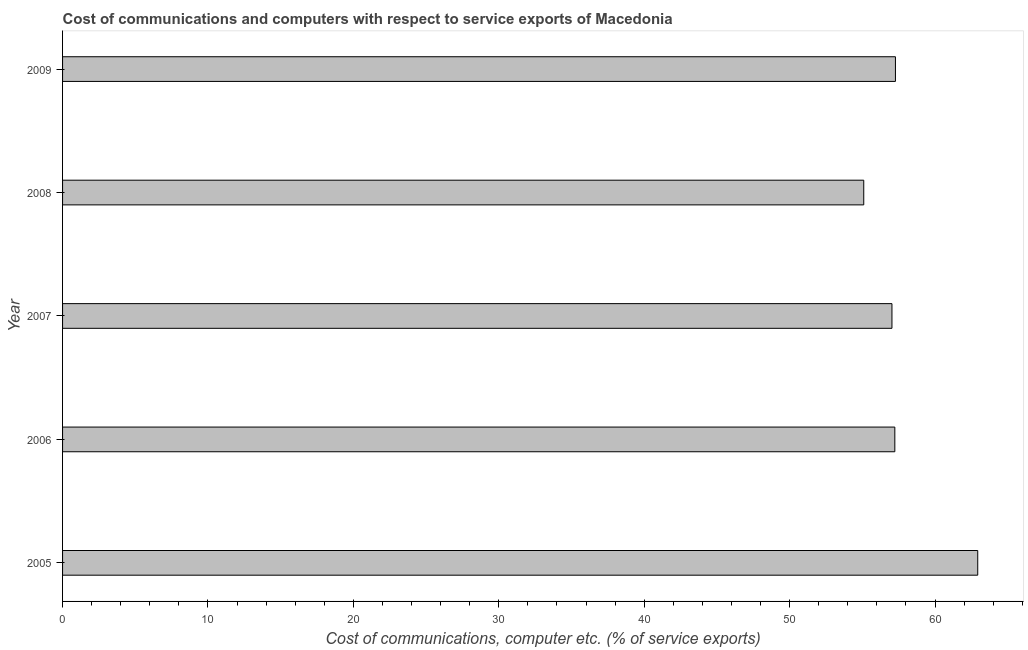Does the graph contain any zero values?
Your answer should be very brief. No. What is the title of the graph?
Provide a succinct answer. Cost of communications and computers with respect to service exports of Macedonia. What is the label or title of the X-axis?
Keep it short and to the point. Cost of communications, computer etc. (% of service exports). What is the cost of communications and computer in 2008?
Offer a terse response. 55.1. Across all years, what is the maximum cost of communications and computer?
Your answer should be compact. 62.94. Across all years, what is the minimum cost of communications and computer?
Your response must be concise. 55.1. In which year was the cost of communications and computer minimum?
Your response must be concise. 2008. What is the sum of the cost of communications and computer?
Offer a very short reply. 289.59. What is the difference between the cost of communications and computer in 2006 and 2009?
Keep it short and to the point. -0.04. What is the average cost of communications and computer per year?
Your response must be concise. 57.92. What is the median cost of communications and computer?
Offer a very short reply. 57.24. In how many years, is the cost of communications and computer greater than 56 %?
Make the answer very short. 4. Do a majority of the years between 2007 and 2005 (inclusive) have cost of communications and computer greater than 60 %?
Offer a terse response. Yes. What is the ratio of the cost of communications and computer in 2005 to that in 2007?
Make the answer very short. 1.1. Is the cost of communications and computer in 2005 less than that in 2008?
Your answer should be very brief. No. Is the difference between the cost of communications and computer in 2007 and 2008 greater than the difference between any two years?
Make the answer very short. No. What is the difference between the highest and the second highest cost of communications and computer?
Provide a short and direct response. 5.66. Is the sum of the cost of communications and computer in 2005 and 2008 greater than the maximum cost of communications and computer across all years?
Offer a terse response. Yes. What is the difference between the highest and the lowest cost of communications and computer?
Your answer should be very brief. 7.84. In how many years, is the cost of communications and computer greater than the average cost of communications and computer taken over all years?
Keep it short and to the point. 1. How many bars are there?
Your response must be concise. 5. Are all the bars in the graph horizontal?
Your answer should be compact. Yes. What is the difference between two consecutive major ticks on the X-axis?
Make the answer very short. 10. Are the values on the major ticks of X-axis written in scientific E-notation?
Make the answer very short. No. What is the Cost of communications, computer etc. (% of service exports) of 2005?
Your response must be concise. 62.94. What is the Cost of communications, computer etc. (% of service exports) in 2006?
Keep it short and to the point. 57.24. What is the Cost of communications, computer etc. (% of service exports) in 2007?
Keep it short and to the point. 57.04. What is the Cost of communications, computer etc. (% of service exports) in 2008?
Keep it short and to the point. 55.1. What is the Cost of communications, computer etc. (% of service exports) in 2009?
Provide a succinct answer. 57.28. What is the difference between the Cost of communications, computer etc. (% of service exports) in 2005 and 2006?
Your answer should be very brief. 5.7. What is the difference between the Cost of communications, computer etc. (% of service exports) in 2005 and 2007?
Keep it short and to the point. 5.9. What is the difference between the Cost of communications, computer etc. (% of service exports) in 2005 and 2008?
Your answer should be very brief. 7.84. What is the difference between the Cost of communications, computer etc. (% of service exports) in 2005 and 2009?
Make the answer very short. 5.66. What is the difference between the Cost of communications, computer etc. (% of service exports) in 2006 and 2007?
Ensure brevity in your answer.  0.2. What is the difference between the Cost of communications, computer etc. (% of service exports) in 2006 and 2008?
Offer a very short reply. 2.14. What is the difference between the Cost of communications, computer etc. (% of service exports) in 2006 and 2009?
Keep it short and to the point. -0.04. What is the difference between the Cost of communications, computer etc. (% of service exports) in 2007 and 2008?
Your answer should be very brief. 1.94. What is the difference between the Cost of communications, computer etc. (% of service exports) in 2007 and 2009?
Your answer should be compact. -0.24. What is the difference between the Cost of communications, computer etc. (% of service exports) in 2008 and 2009?
Provide a short and direct response. -2.18. What is the ratio of the Cost of communications, computer etc. (% of service exports) in 2005 to that in 2007?
Keep it short and to the point. 1.1. What is the ratio of the Cost of communications, computer etc. (% of service exports) in 2005 to that in 2008?
Ensure brevity in your answer.  1.14. What is the ratio of the Cost of communications, computer etc. (% of service exports) in 2005 to that in 2009?
Your answer should be very brief. 1.1. What is the ratio of the Cost of communications, computer etc. (% of service exports) in 2006 to that in 2008?
Give a very brief answer. 1.04. What is the ratio of the Cost of communications, computer etc. (% of service exports) in 2006 to that in 2009?
Keep it short and to the point. 1. What is the ratio of the Cost of communications, computer etc. (% of service exports) in 2007 to that in 2008?
Keep it short and to the point. 1.03. 